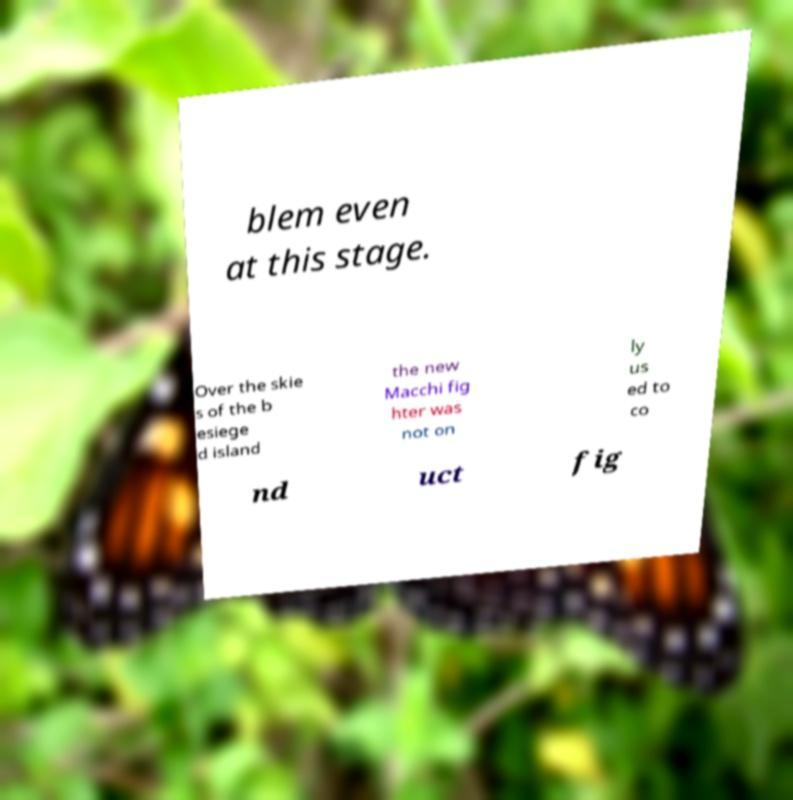I need the written content from this picture converted into text. Can you do that? blem even at this stage. Over the skie s of the b esiege d island the new Macchi fig hter was not on ly us ed to co nd uct fig 